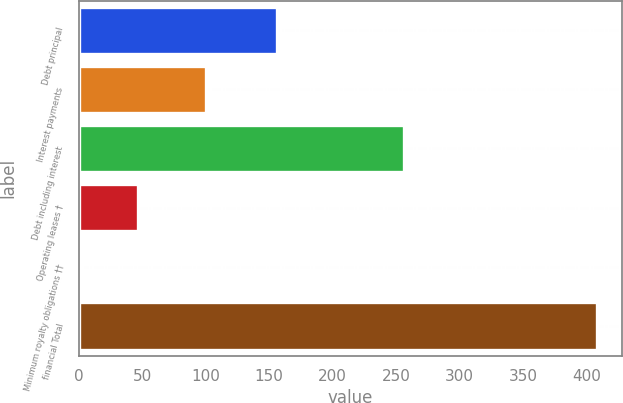<chart> <loc_0><loc_0><loc_500><loc_500><bar_chart><fcel>Debt principal<fcel>Interest payments<fcel>Debt including interest<fcel>Operating leases †<fcel>Minimum royalty obligations ††<fcel>financial Total<nl><fcel>156<fcel>100<fcel>256<fcel>47<fcel>3<fcel>408<nl></chart> 